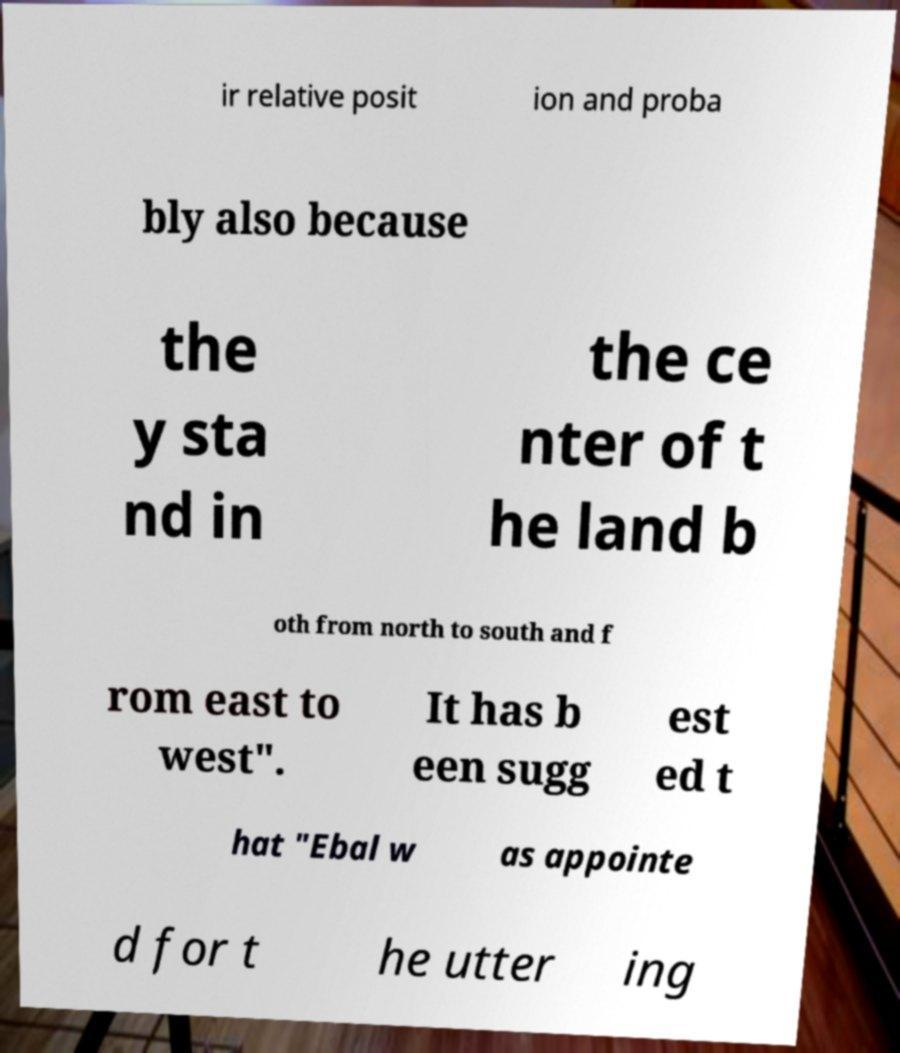What messages or text are displayed in this image? I need them in a readable, typed format. ir relative posit ion and proba bly also because the y sta nd in the ce nter of t he land b oth from north to south and f rom east to west". It has b een sugg est ed t hat "Ebal w as appointe d for t he utter ing 